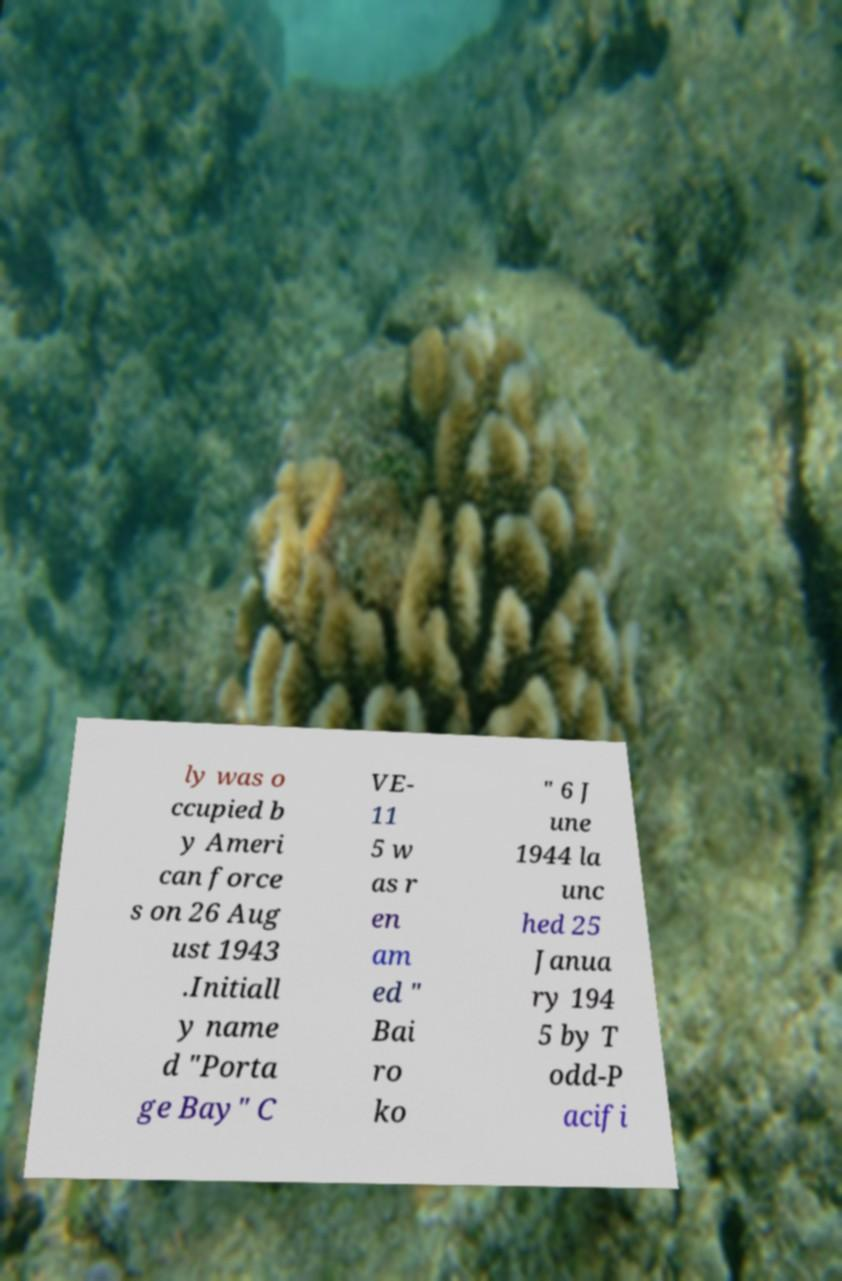Please identify and transcribe the text found in this image. ly was o ccupied b y Ameri can force s on 26 Aug ust 1943 .Initiall y name d "Porta ge Bay" C VE- 11 5 w as r en am ed " Bai ro ko " 6 J une 1944 la unc hed 25 Janua ry 194 5 by T odd-P acifi 